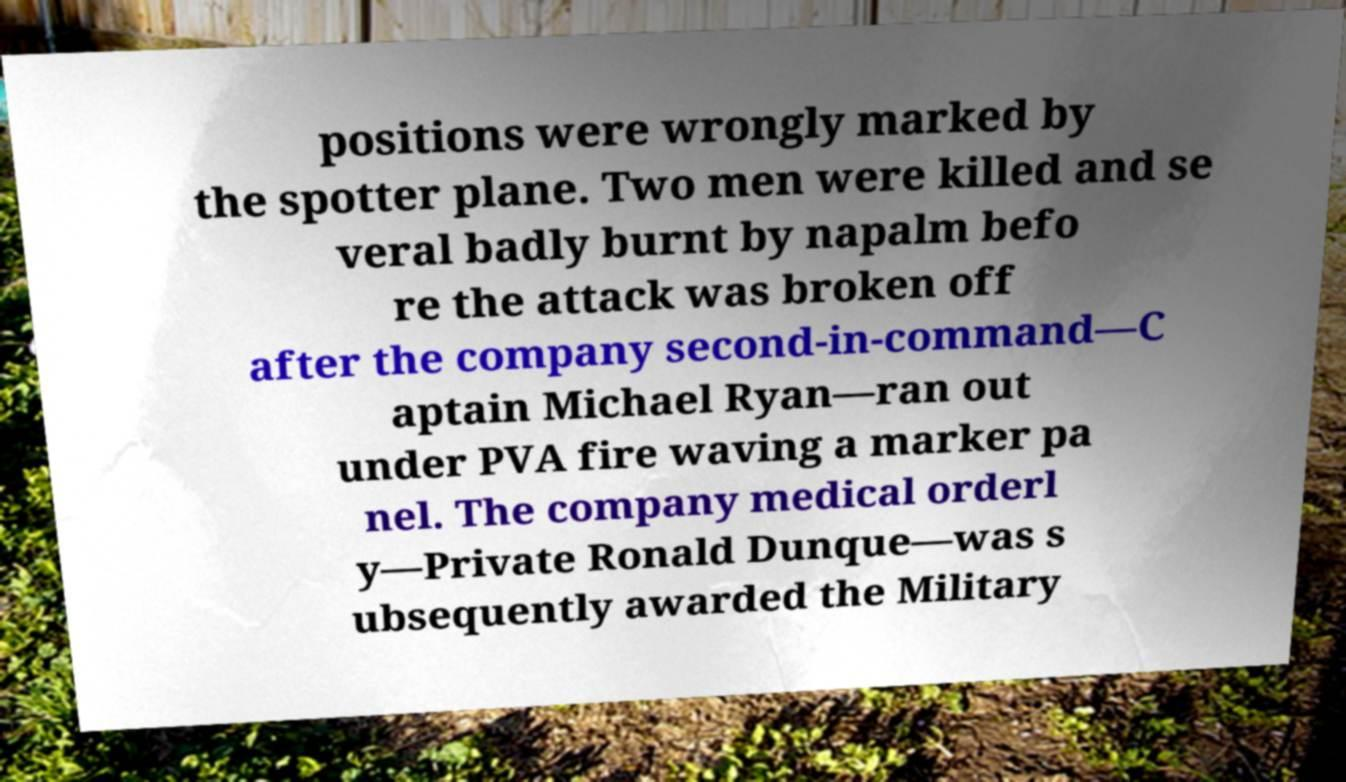Could you assist in decoding the text presented in this image and type it out clearly? positions were wrongly marked by the spotter plane. Two men were killed and se veral badly burnt by napalm befo re the attack was broken off after the company second-in-command—C aptain Michael Ryan—ran out under PVA fire waving a marker pa nel. The company medical orderl y—Private Ronald Dunque—was s ubsequently awarded the Military 